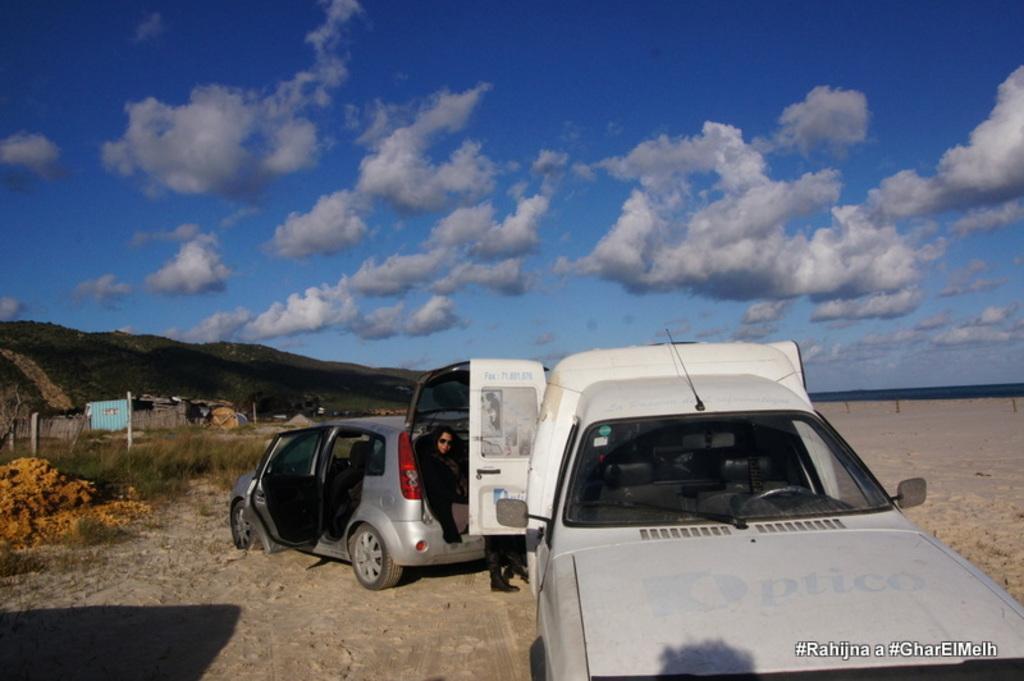In one or two sentences, can you explain what this image depicts? In this image a person is sitting in a car. There are two vehicles in the image. There are many hills in the image. There is a clouded and blue sky in the image. 